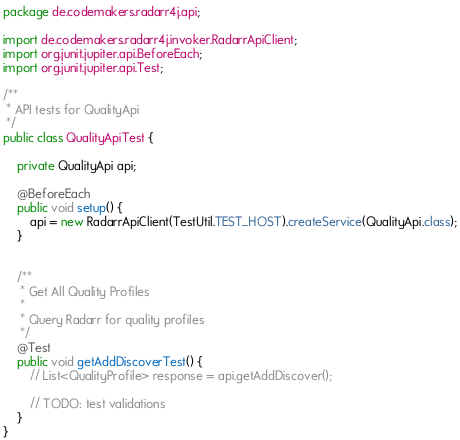<code> <loc_0><loc_0><loc_500><loc_500><_Java_>package de.codemakers.radarr4j.api;

import de.codemakers.radarr4j.invoker.RadarrApiClient;
import org.junit.jupiter.api.BeforeEach;
import org.junit.jupiter.api.Test;

/**
 * API tests for QualityApi
 */
public class QualityApiTest {

    private QualityApi api;

    @BeforeEach
    public void setup() {
        api = new RadarrApiClient(TestUtil.TEST_HOST).createService(QualityApi.class);
    }


    /**
     * Get All Quality Profiles
     *
     * Query Radarr for quality profiles 
     */
    @Test
    public void getAddDiscoverTest() {
        // List<QualityProfile> response = api.getAddDiscover();

        // TODO: test validations
    }
}
</code> 